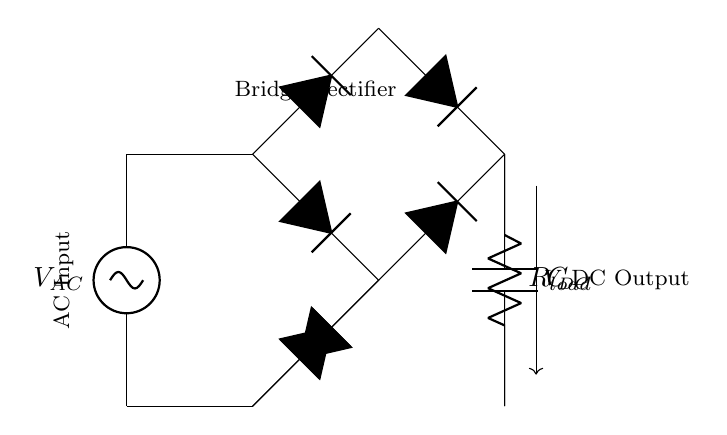What type of rectifier is shown in the circuit? The circuit diagram represents a bridge rectifier, which consists of four diodes arranged to convert AC input into DC output. It can be identified by the presence of the four diodes and its configuration.
Answer: Bridge rectifier How many diodes are used in this circuit? The bridge rectifier circuit features four diodes arranged in a specific manner to effectively convert AC to DC. Counting the diodes displayed in the diagram reveals this information.
Answer: Four What is the purpose of the capacitor in this circuit? The capacitor serves to smooth the output voltage after rectification. It stores electrical energy and releases it, reducing voltage ripples and providing a more stable DC output.
Answer: Smoothing the output What is the function of the load resistor in this circuit? The load resistor is typically where the electrical power is utilized. It represents the devices or appliances that operate using the DC output supplied by the rectifier circuit.
Answer: Power utilization What is the input type of this circuit? The input to this bridge rectifier circuit is AC, which is indicated in the diagram's labels. The AC source supplies the alternating current needed for rectification.
Answer: AC What happens to the output voltage if the load resistance is increased significantly? Increasing the load resistance will result in a decrease in the output current, which can lead to a slight increase in the output voltage due to reduced voltage drop across components; however, the effect is modest in ideal conditions.
Answer: Voltage increase What is the expected output type of this circuit? The expected output type of this rectifier circuit is DC, as the purpose of a bridge rectifier is to convert alternating current into direct current for use in household appliances and electronic devices.
Answer: DC 